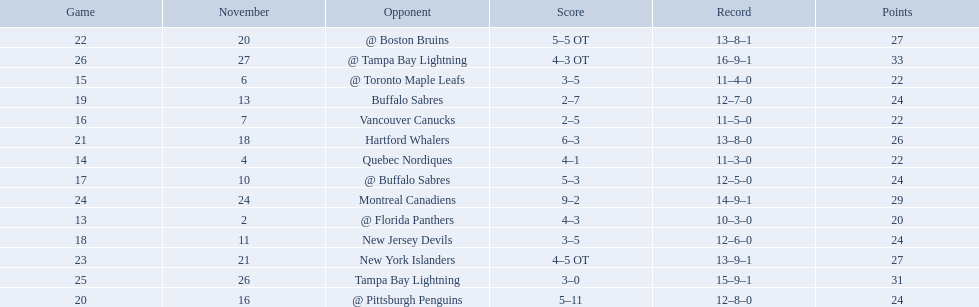Can you parse all the data within this table? {'header': ['Game', 'November', 'Opponent', 'Score', 'Record', 'Points'], 'rows': [['22', '20', '@ Boston Bruins', '5–5 OT', '13–8–1', '27'], ['26', '27', '@ Tampa Bay Lightning', '4–3 OT', '16–9–1', '33'], ['15', '6', '@ Toronto Maple Leafs', '3–5', '11–4–0', '22'], ['19', '13', 'Buffalo Sabres', '2–7', '12–7–0', '24'], ['16', '7', 'Vancouver Canucks', '2–5', '11–5–0', '22'], ['21', '18', 'Hartford Whalers', '6–3', '13–8–0', '26'], ['14', '4', 'Quebec Nordiques', '4–1', '11–3–0', '22'], ['17', '10', '@ Buffalo Sabres', '5–3', '12–5–0', '24'], ['24', '24', 'Montreal Canadiens', '9–2', '14–9–1', '29'], ['13', '2', '@ Florida Panthers', '4–3', '10–3–0', '20'], ['18', '11', 'New Jersey Devils', '3–5', '12–6–0', '24'], ['23', '21', 'New York Islanders', '4–5 OT', '13–9–1', '27'], ['25', '26', 'Tampa Bay Lightning', '3–0', '15–9–1', '31'], ['20', '16', '@ Pittsburgh Penguins', '5–11', '12–8–0', '24']]} Who are all of the teams? @ Florida Panthers, Quebec Nordiques, @ Toronto Maple Leafs, Vancouver Canucks, @ Buffalo Sabres, New Jersey Devils, Buffalo Sabres, @ Pittsburgh Penguins, Hartford Whalers, @ Boston Bruins, New York Islanders, Montreal Canadiens, Tampa Bay Lightning. What games finished in overtime? 22, 23, 26. In game number 23, who did they face? New York Islanders. 